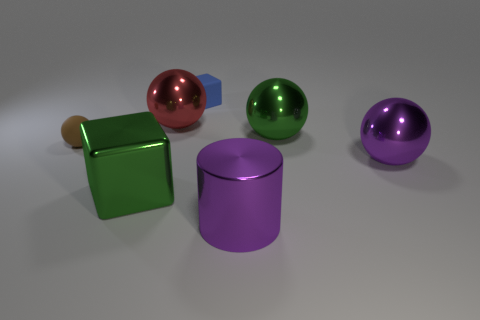Are there any other things that have the same size as the blue matte cube?
Give a very brief answer. Yes. There is a purple metallic object that is behind the purple shiny cylinder; is it the same shape as the blue matte thing?
Your answer should be very brief. No. Are there more purple metal objects that are to the right of the metal cylinder than small brown spheres?
Your response must be concise. No. There is a block behind the purple thing that is right of the green sphere; what is its color?
Keep it short and to the point. Blue. How many yellow shiny objects are there?
Keep it short and to the point. 0. What number of objects are both on the left side of the purple sphere and behind the big purple cylinder?
Your answer should be very brief. 5. Is there anything else that has the same shape as the red object?
Give a very brief answer. Yes. There is a big cylinder; is it the same color as the tiny rubber object behind the green sphere?
Keep it short and to the point. No. What is the shape of the green object right of the red thing?
Offer a terse response. Sphere. What number of other things are the same material as the blue block?
Give a very brief answer. 1. 